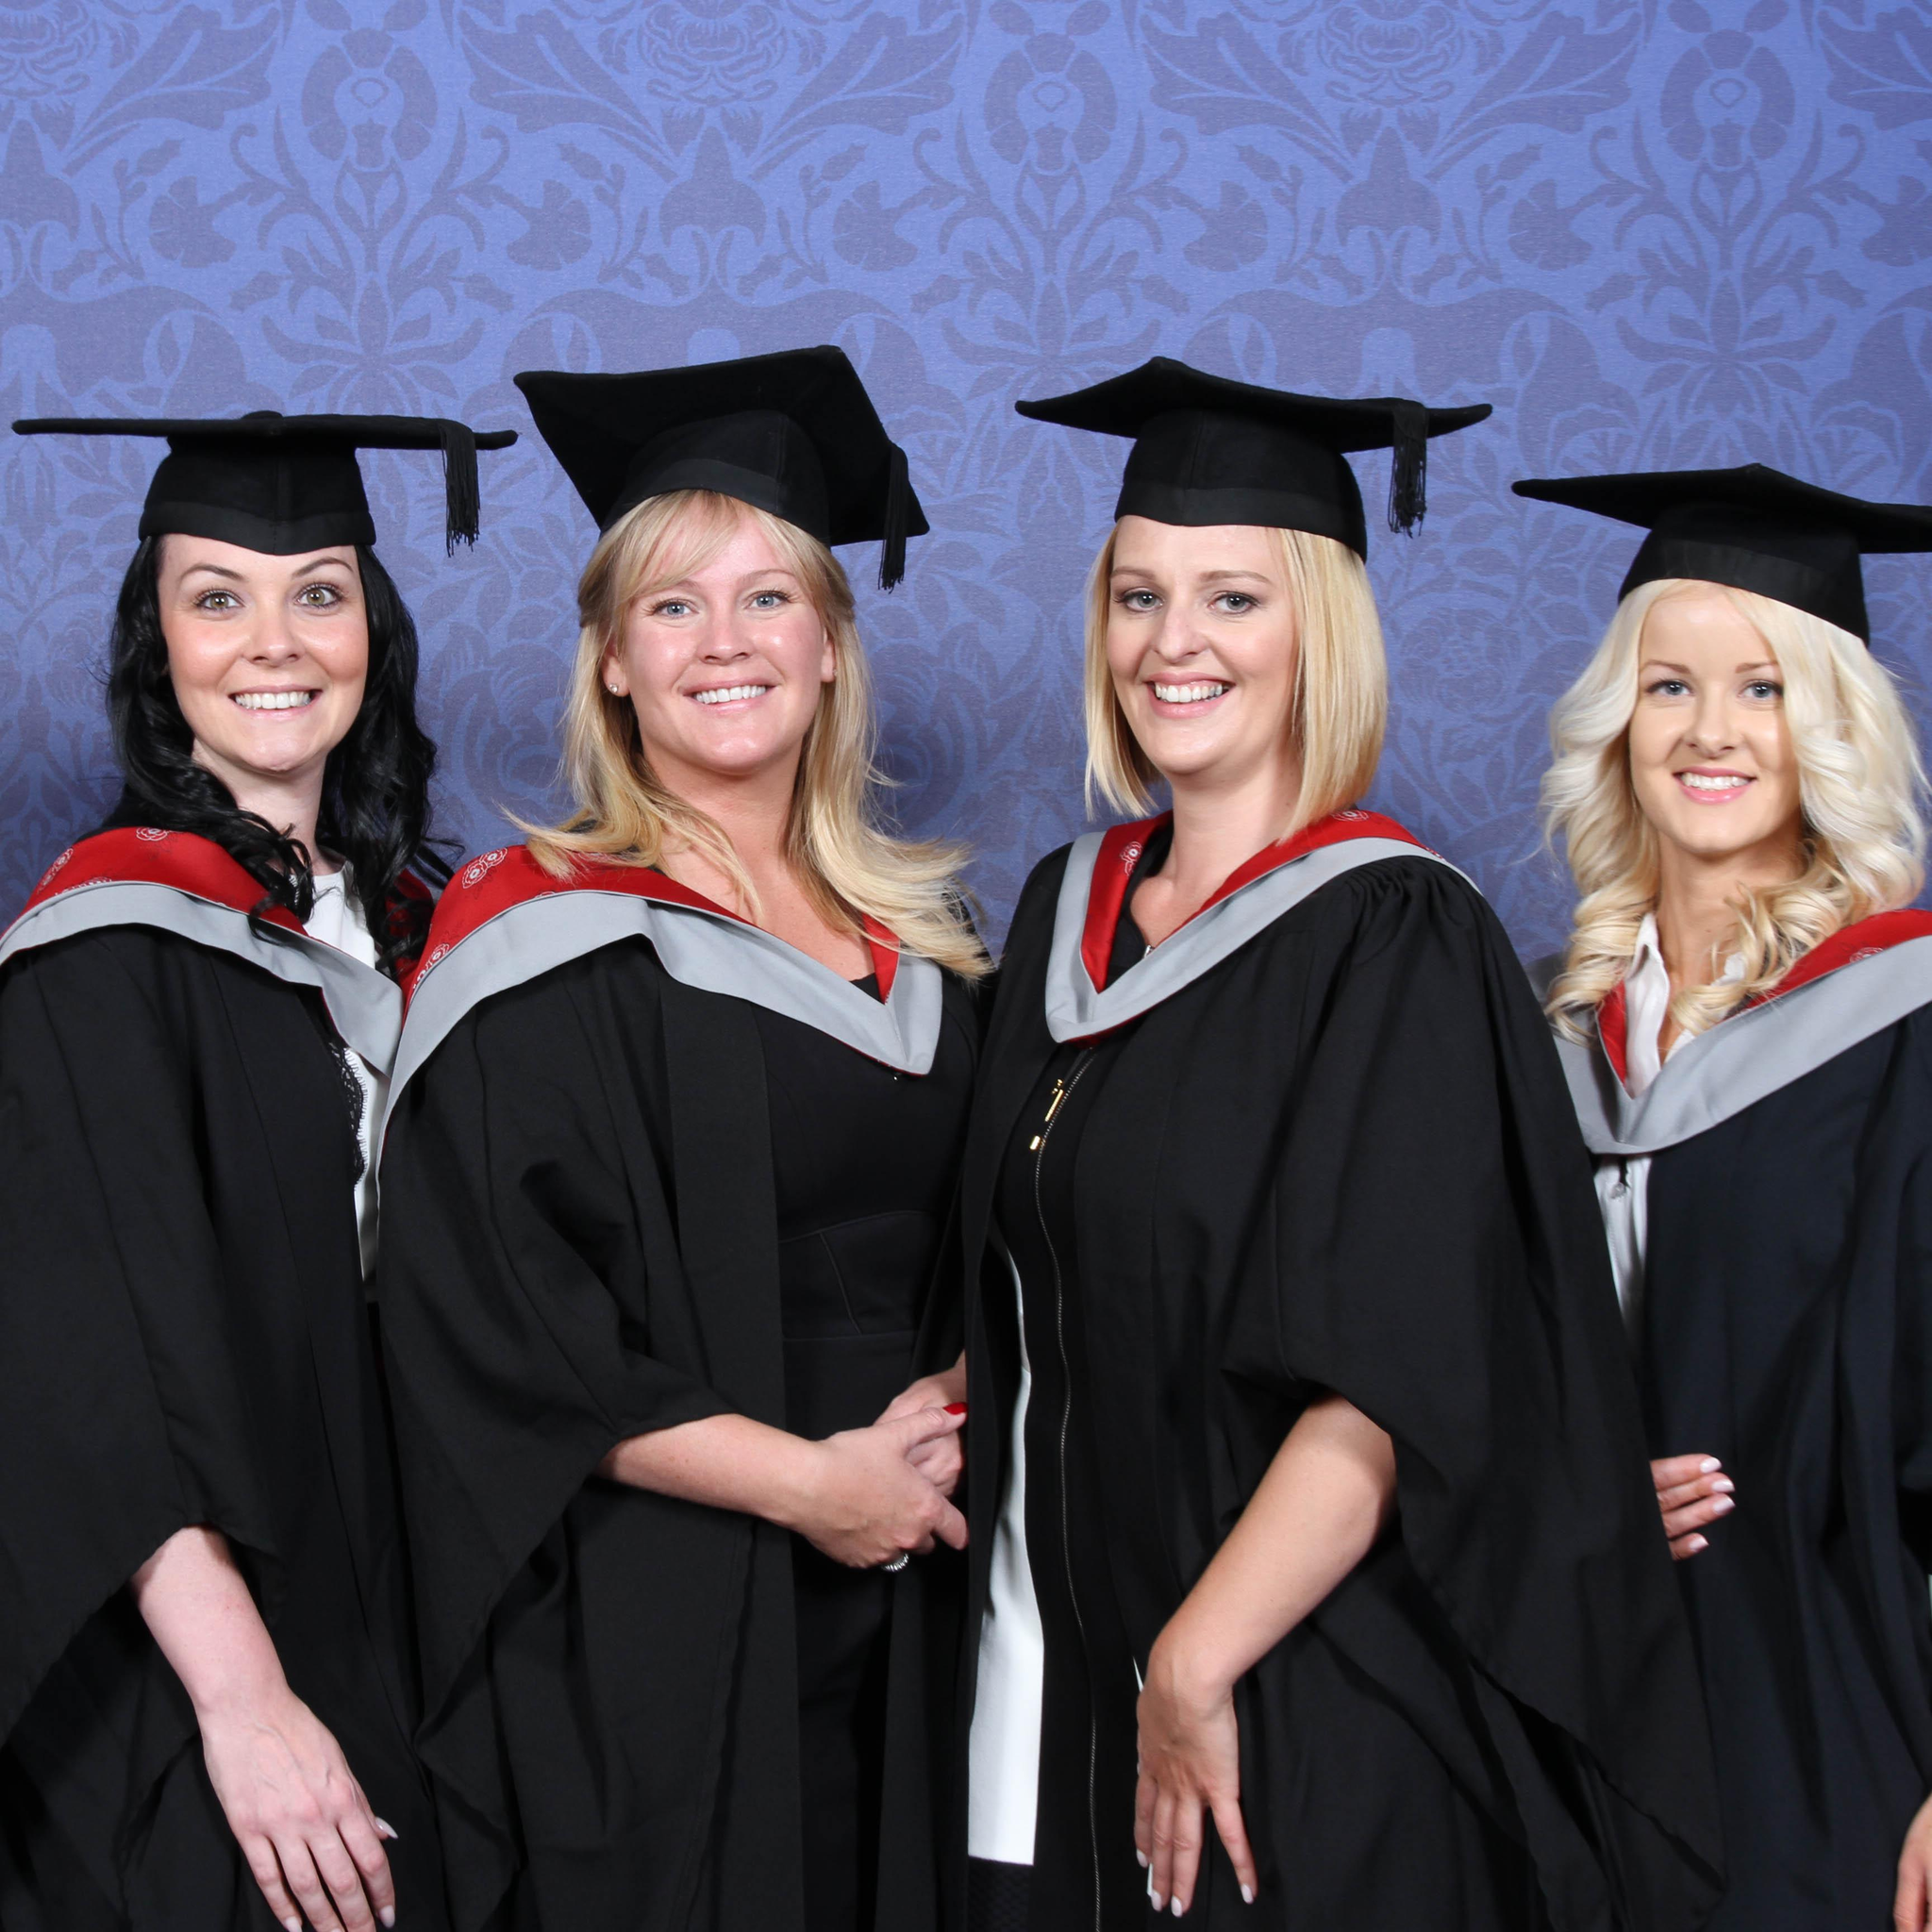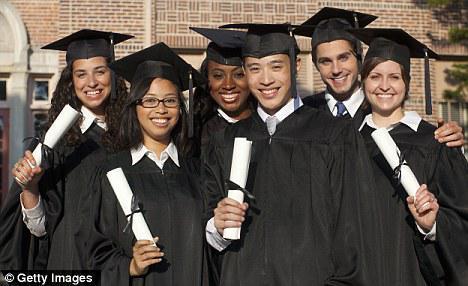The first image is the image on the left, the second image is the image on the right. Assess this claim about the two images: "An image includes three blond girls in graduation garb, posed side-by-side in a straight row.". Correct or not? Answer yes or no. Yes. The first image is the image on the left, the second image is the image on the right. Analyze the images presented: Is the assertion "There are only women in the left image, but both men and women on the right." valid? Answer yes or no. Yes. 